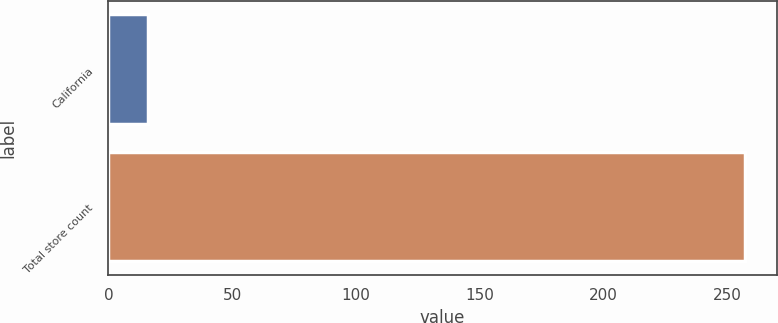<chart> <loc_0><loc_0><loc_500><loc_500><bar_chart><fcel>California<fcel>Total store count<nl><fcel>16<fcel>257<nl></chart> 